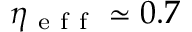<formula> <loc_0><loc_0><loc_500><loc_500>\eta _ { e f f } \simeq 0 . 7</formula> 